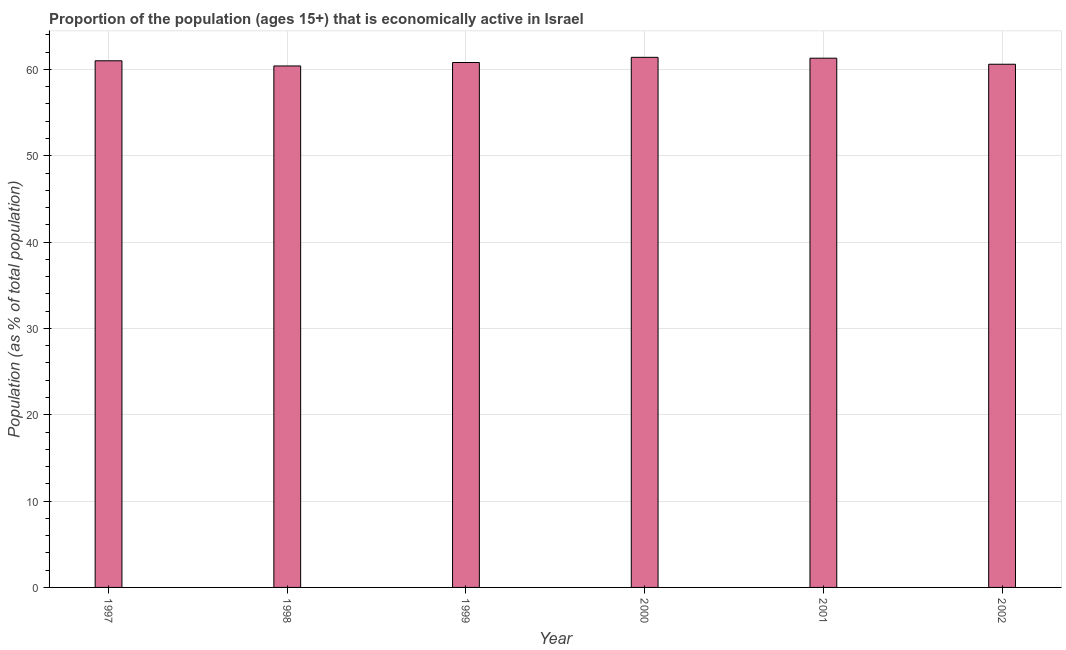Does the graph contain grids?
Make the answer very short. Yes. What is the title of the graph?
Your response must be concise. Proportion of the population (ages 15+) that is economically active in Israel. What is the label or title of the X-axis?
Make the answer very short. Year. What is the label or title of the Y-axis?
Keep it short and to the point. Population (as % of total population). What is the percentage of economically active population in 1997?
Your response must be concise. 61. Across all years, what is the maximum percentage of economically active population?
Offer a terse response. 61.4. Across all years, what is the minimum percentage of economically active population?
Your answer should be compact. 60.4. What is the sum of the percentage of economically active population?
Offer a terse response. 365.5. What is the difference between the percentage of economically active population in 1998 and 2001?
Provide a succinct answer. -0.9. What is the average percentage of economically active population per year?
Keep it short and to the point. 60.92. What is the median percentage of economically active population?
Provide a short and direct response. 60.9. In how many years, is the percentage of economically active population greater than 18 %?
Offer a very short reply. 6. Do a majority of the years between 2002 and 2000 (inclusive) have percentage of economically active population greater than 36 %?
Your answer should be compact. Yes. What is the ratio of the percentage of economically active population in 1998 to that in 2002?
Offer a terse response. 1. What is the difference between the highest and the second highest percentage of economically active population?
Keep it short and to the point. 0.1. In how many years, is the percentage of economically active population greater than the average percentage of economically active population taken over all years?
Provide a short and direct response. 3. Are all the bars in the graph horizontal?
Your response must be concise. No. What is the Population (as % of total population) in 1998?
Provide a short and direct response. 60.4. What is the Population (as % of total population) in 1999?
Offer a very short reply. 60.8. What is the Population (as % of total population) of 2000?
Make the answer very short. 61.4. What is the Population (as % of total population) of 2001?
Keep it short and to the point. 61.3. What is the Population (as % of total population) of 2002?
Offer a terse response. 60.6. What is the difference between the Population (as % of total population) in 1997 and 1999?
Your answer should be compact. 0.2. What is the difference between the Population (as % of total population) in 1997 and 2001?
Your answer should be compact. -0.3. What is the difference between the Population (as % of total population) in 1998 and 1999?
Your answer should be compact. -0.4. What is the difference between the Population (as % of total population) in 1998 and 2000?
Offer a very short reply. -1. What is the difference between the Population (as % of total population) in 1998 and 2001?
Offer a very short reply. -0.9. What is the ratio of the Population (as % of total population) in 1997 to that in 1998?
Provide a succinct answer. 1.01. What is the ratio of the Population (as % of total population) in 1997 to that in 1999?
Provide a short and direct response. 1. What is the ratio of the Population (as % of total population) in 1997 to that in 2001?
Keep it short and to the point. 0.99. What is the ratio of the Population (as % of total population) in 1997 to that in 2002?
Provide a short and direct response. 1.01. What is the ratio of the Population (as % of total population) in 1998 to that in 1999?
Make the answer very short. 0.99. What is the ratio of the Population (as % of total population) in 1999 to that in 2001?
Your response must be concise. 0.99. What is the ratio of the Population (as % of total population) in 1999 to that in 2002?
Your response must be concise. 1. What is the ratio of the Population (as % of total population) in 2000 to that in 2001?
Ensure brevity in your answer.  1. What is the ratio of the Population (as % of total population) in 2001 to that in 2002?
Give a very brief answer. 1.01. 